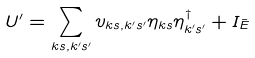Convert formula to latex. <formula><loc_0><loc_0><loc_500><loc_500>U ^ { \prime } = \sum _ { k s , k ^ { \prime } s ^ { \prime } } v _ { k s , k ^ { \prime } s ^ { \prime } } \eta _ { k s } \eta _ { k ^ { \prime } s ^ { \prime } } ^ { \dag } + I _ { \bar { E } }</formula> 